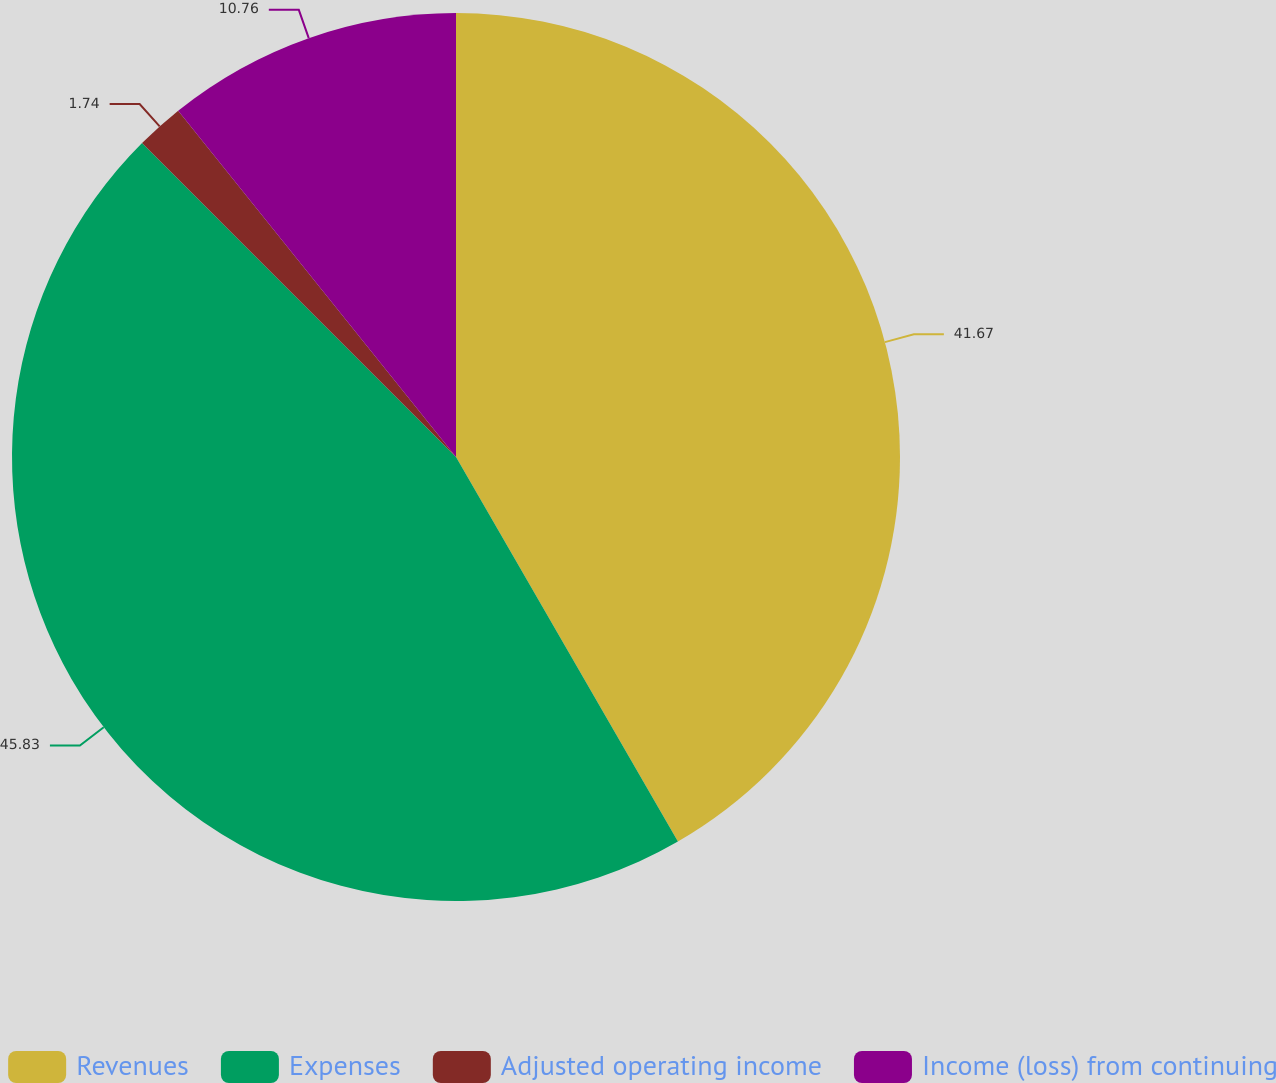<chart> <loc_0><loc_0><loc_500><loc_500><pie_chart><fcel>Revenues<fcel>Expenses<fcel>Adjusted operating income<fcel>Income (loss) from continuing<nl><fcel>41.67%<fcel>45.83%<fcel>1.74%<fcel>10.76%<nl></chart> 